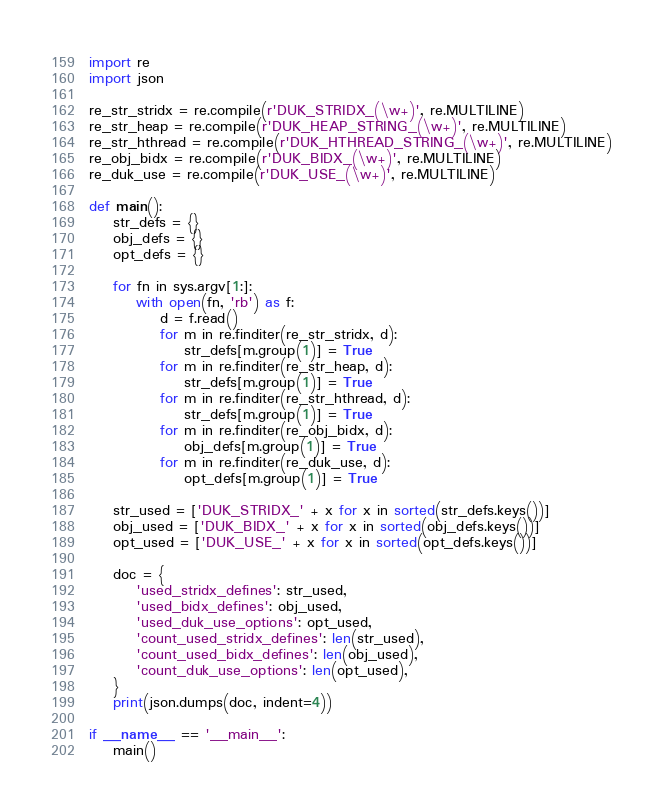<code> <loc_0><loc_0><loc_500><loc_500><_Python_>import re
import json

re_str_stridx = re.compile(r'DUK_STRIDX_(\w+)', re.MULTILINE)
re_str_heap = re.compile(r'DUK_HEAP_STRING_(\w+)', re.MULTILINE)
re_str_hthread = re.compile(r'DUK_HTHREAD_STRING_(\w+)', re.MULTILINE)
re_obj_bidx = re.compile(r'DUK_BIDX_(\w+)', re.MULTILINE)
re_duk_use = re.compile(r'DUK_USE_(\w+)', re.MULTILINE)

def main():
    str_defs = {}
    obj_defs = {}
    opt_defs = {}

    for fn in sys.argv[1:]:
        with open(fn, 'rb') as f:
            d = f.read()
            for m in re.finditer(re_str_stridx, d):
                str_defs[m.group(1)] = True
            for m in re.finditer(re_str_heap, d):
                str_defs[m.group(1)] = True
            for m in re.finditer(re_str_hthread, d):
                str_defs[m.group(1)] = True
            for m in re.finditer(re_obj_bidx, d):
                obj_defs[m.group(1)] = True
            for m in re.finditer(re_duk_use, d):
                opt_defs[m.group(1)] = True

    str_used = ['DUK_STRIDX_' + x for x in sorted(str_defs.keys())]
    obj_used = ['DUK_BIDX_' + x for x in sorted(obj_defs.keys())]
    opt_used = ['DUK_USE_' + x for x in sorted(opt_defs.keys())]

    doc = {
        'used_stridx_defines': str_used,
        'used_bidx_defines': obj_used,
        'used_duk_use_options': opt_used,
        'count_used_stridx_defines': len(str_used),
        'count_used_bidx_defines': len(obj_used),
        'count_duk_use_options': len(opt_used),
    }
    print(json.dumps(doc, indent=4))

if __name__ == '__main__':
    main()
</code> 